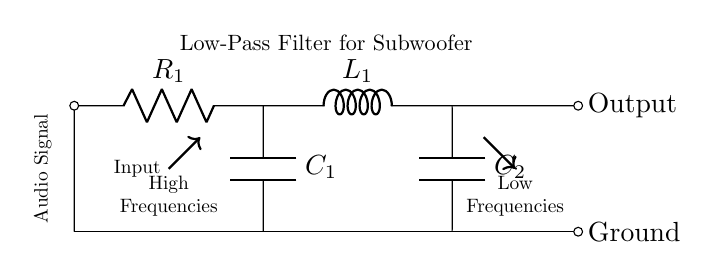What is the first component in the circuit? The first component in the circuit is a resistor, labeled as R1, which is connected at the input of the circuit.
Answer: Resistor What types of components are present in this circuit? The circuit diagram contains resistors, inductors, and capacitors, which are the primary components used in a low-pass filter.
Answer: Resistors, inductors, capacitors What is the purpose of the low-pass filter? The purpose of the low-pass filter is to allow low frequencies to pass through while attenuating high frequencies, making it suitable for subwoofer applications.
Answer: Attenuate high frequencies Where does the audio signal enter the circuit? The audio signal enters the circuit on the left side, where input is indicated, and flows through R1.
Answer: Left side What is the output frequency range after this filter? The output frequency range after this filter consists mainly of low frequencies, as indicated by the arrow going from the circuit showing low frequencies out.
Answer: Low frequencies How does the addition of capacitors affect the filter characteristics? The addition of capacitors in parallel with the inductor affects the cutoff frequency of the low-pass filter, allowing for more control over the frequencies that are passed through. This setup typically shifts the response curve, affecting the filter's behavior.
Answer: Controls cutoff frequency What is the significance of the ground in this circuit? The ground serves as a reference point for the circuit, providing a return path for current and stabilizing the voltage levels of the components. It is essential for the proper functioning of the circuit.
Answer: Reference point 